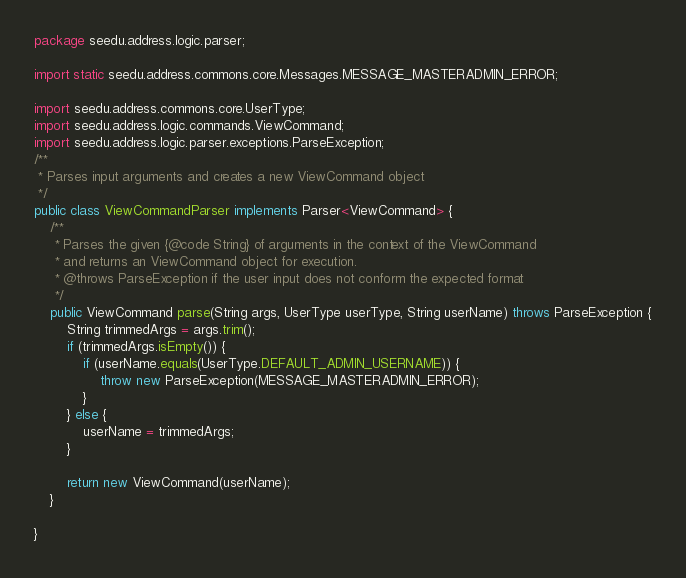Convert code to text. <code><loc_0><loc_0><loc_500><loc_500><_Java_>package seedu.address.logic.parser;

import static seedu.address.commons.core.Messages.MESSAGE_MASTERADMIN_ERROR;

import seedu.address.commons.core.UserType;
import seedu.address.logic.commands.ViewCommand;
import seedu.address.logic.parser.exceptions.ParseException;
/**
 * Parses input arguments and creates a new ViewCommand object
 */
public class ViewCommandParser implements Parser<ViewCommand> {
    /**
     * Parses the given {@code String} of arguments in the context of the ViewCommand
     * and returns an ViewCommand object for execution.
     * @throws ParseException if the user input does not conform the expected format
     */
    public ViewCommand parse(String args, UserType userType, String userName) throws ParseException {
        String trimmedArgs = args.trim();
        if (trimmedArgs.isEmpty()) {
            if (userName.equals(UserType.DEFAULT_ADMIN_USERNAME)) {
                throw new ParseException(MESSAGE_MASTERADMIN_ERROR);
            }
        } else {
            userName = trimmedArgs;
        }

        return new ViewCommand(userName);
    }

}
</code> 